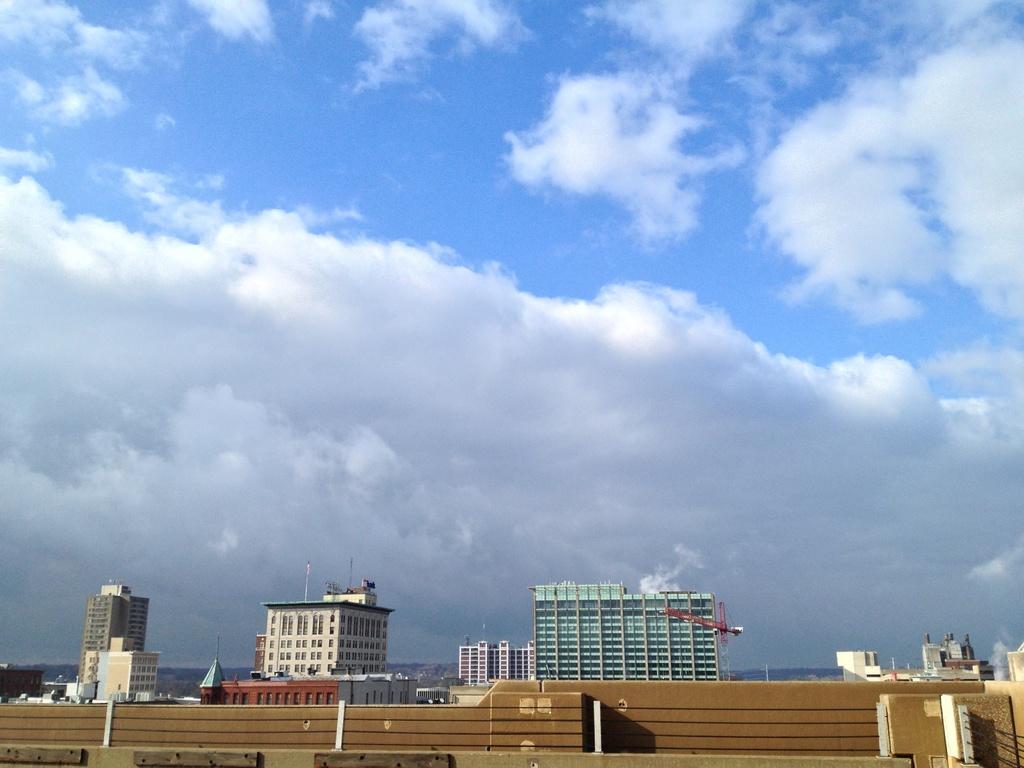Please provide a concise description of this image. At the bottom we can see the wall and on the right there is a fence. In the background there are buildings,crane,poles,windows,glass doors,roof and clouds in the sky. 